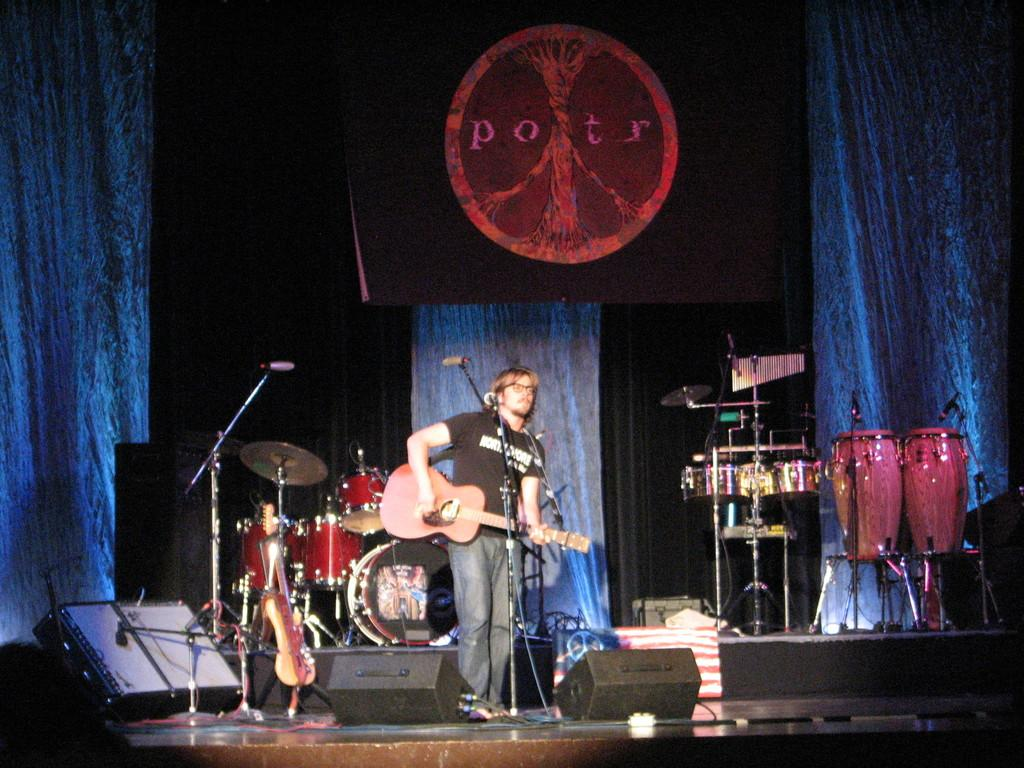What is the main subject of the image? There is a person in the image. What is the person holding in the image? The person is holding a guitar. What other musical instrument can be seen in the image? There are drums visible in the image. What is the health condition of the person's father in the image? There is no information about the person's father or their health condition in the image. 